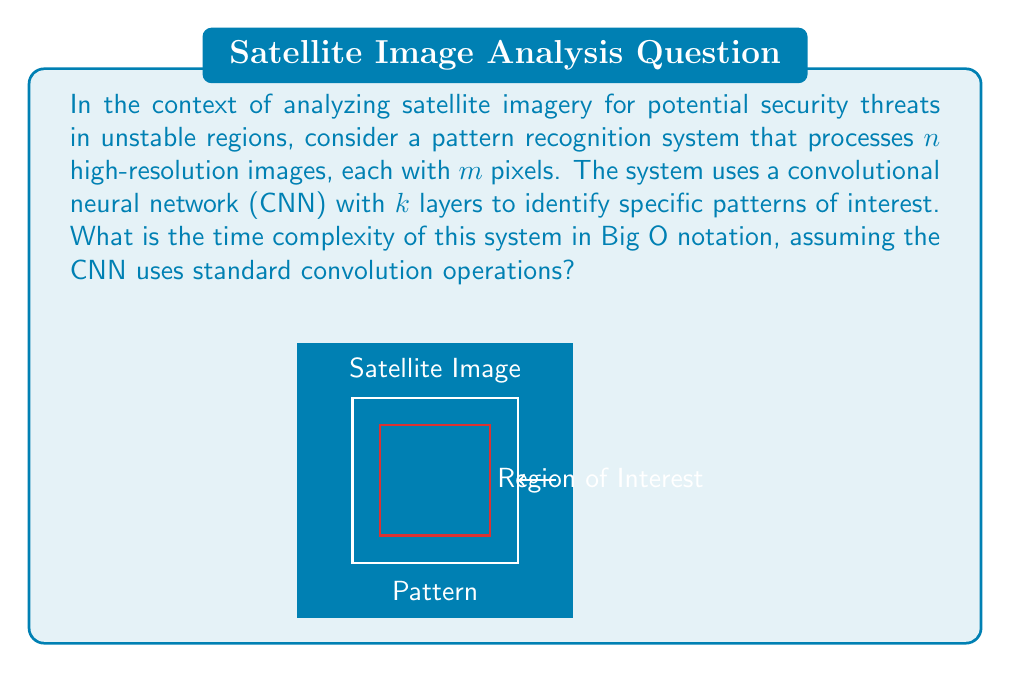Provide a solution to this math problem. To determine the time complexity of the pattern recognition system, we need to consider the following steps:

1) Image processing: Each of the $n$ images with $m$ pixels needs to be processed. This gives us a base complexity of $O(nm)$.

2) CNN operations: For each image, we need to perform convolutions through $k$ layers. The time complexity of a standard convolution operation on an image with $m$ pixels is $O(m)$. 

3) CNN layers: As we have $k$ layers, we need to multiply the convolution complexity by $k$.

4) Combining steps: We perform these CNN operations on each of the $n$ images.

Therefore, the overall time complexity can be calculated as follows:

$$O(nm \cdot k \cdot m) = O(nmk \cdot m) = O(nm^2k)$$

This complexity assumes that the size of the convolution kernels is constant and doesn't grow with the input size, which is typically the case in CNNs used for image analysis.

It's worth noting that this is a simplified analysis. In practice, the complexity might be slightly different due to optimizations in CNN implementations, parallel processing capabilities, or the use of specialized hardware like GPUs.
Answer: $O(nm^2k)$ 